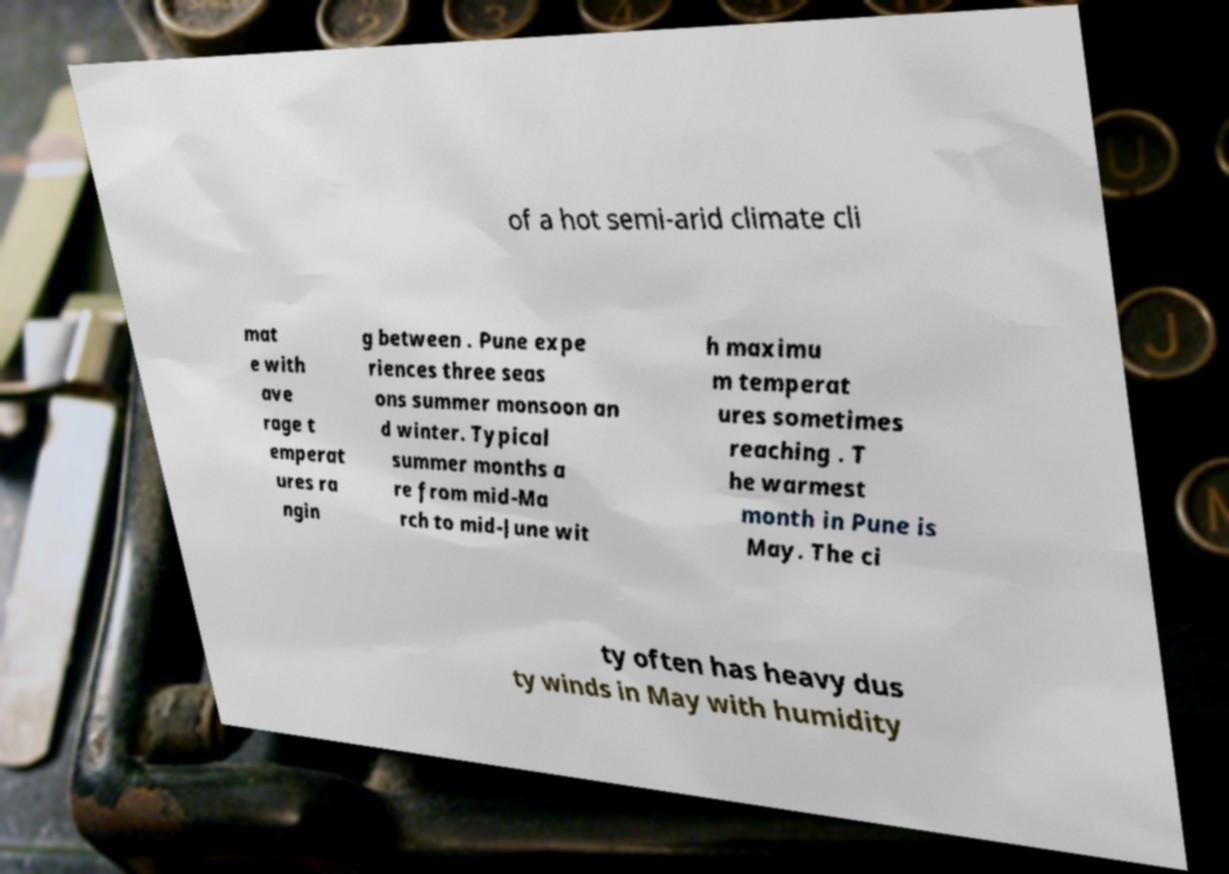There's text embedded in this image that I need extracted. Can you transcribe it verbatim? of a hot semi-arid climate cli mat e with ave rage t emperat ures ra ngin g between . Pune expe riences three seas ons summer monsoon an d winter. Typical summer months a re from mid-Ma rch to mid-June wit h maximu m temperat ures sometimes reaching . T he warmest month in Pune is May. The ci ty often has heavy dus ty winds in May with humidity 